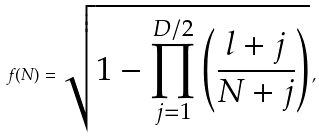Convert formula to latex. <formula><loc_0><loc_0><loc_500><loc_500>f ( N ) = \sqrt { 1 - \prod _ { j = 1 } ^ { D / 2 } \left ( \frac { l + j } { N + j } \right ) } \, ,</formula> 